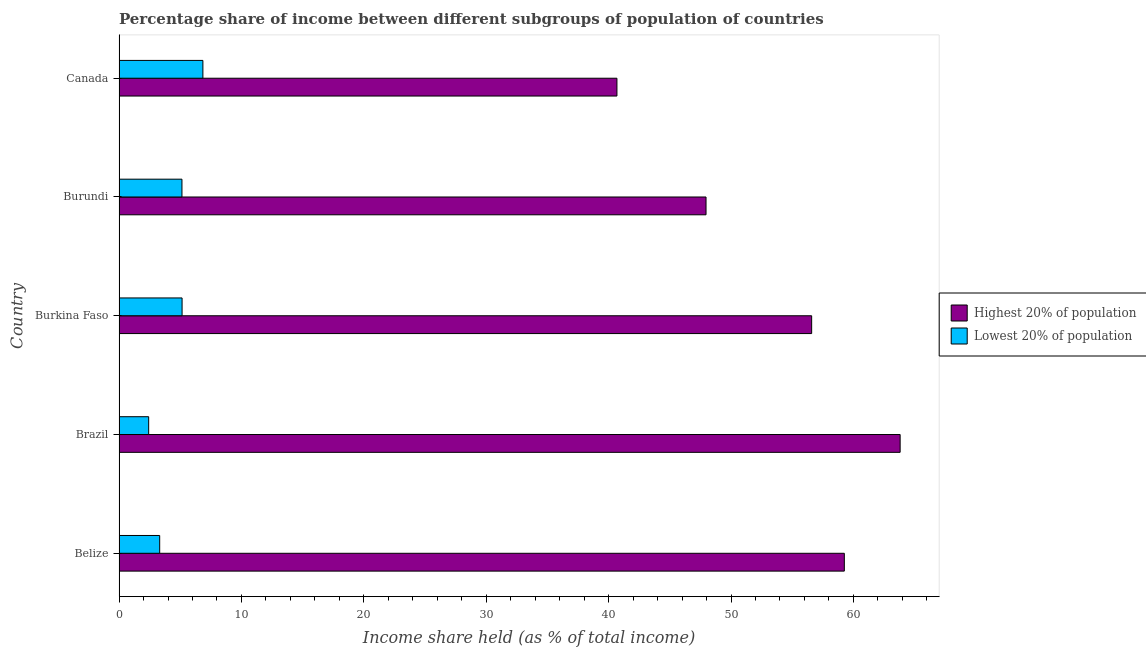How many groups of bars are there?
Your answer should be very brief. 5. Are the number of bars per tick equal to the number of legend labels?
Offer a very short reply. Yes. How many bars are there on the 2nd tick from the bottom?
Offer a terse response. 2. What is the label of the 2nd group of bars from the top?
Give a very brief answer. Burundi. In how many cases, is the number of bars for a given country not equal to the number of legend labels?
Offer a terse response. 0. What is the income share held by highest 20% of the population in Belize?
Your response must be concise. 59.26. Across all countries, what is the maximum income share held by highest 20% of the population?
Give a very brief answer. 63.82. Across all countries, what is the minimum income share held by lowest 20% of the population?
Keep it short and to the point. 2.42. In which country was the income share held by lowest 20% of the population minimum?
Provide a short and direct response. Brazil. What is the total income share held by highest 20% of the population in the graph?
Offer a terse response. 268.31. What is the difference between the income share held by highest 20% of the population in Belize and that in Burundi?
Offer a very short reply. 11.3. What is the difference between the income share held by lowest 20% of the population in Brazil and the income share held by highest 20% of the population in Burkina Faso?
Your answer should be very brief. -54.17. What is the average income share held by lowest 20% of the population per country?
Provide a short and direct response. 4.58. What is the difference between the income share held by highest 20% of the population and income share held by lowest 20% of the population in Burkina Faso?
Provide a short and direct response. 51.44. What is the ratio of the income share held by highest 20% of the population in Brazil to that in Burundi?
Give a very brief answer. 1.33. Is the income share held by lowest 20% of the population in Brazil less than that in Canada?
Give a very brief answer. Yes. Is the difference between the income share held by highest 20% of the population in Belize and Canada greater than the difference between the income share held by lowest 20% of the population in Belize and Canada?
Keep it short and to the point. Yes. What is the difference between the highest and the second highest income share held by lowest 20% of the population?
Offer a terse response. 1.7. What is the difference between the highest and the lowest income share held by highest 20% of the population?
Make the answer very short. 23.14. Is the sum of the income share held by lowest 20% of the population in Belize and Canada greater than the maximum income share held by highest 20% of the population across all countries?
Your response must be concise. No. What does the 2nd bar from the top in Burkina Faso represents?
Ensure brevity in your answer.  Highest 20% of population. What does the 2nd bar from the bottom in Canada represents?
Your answer should be very brief. Lowest 20% of population. What is the difference between two consecutive major ticks on the X-axis?
Your response must be concise. 10. Does the graph contain grids?
Provide a succinct answer. No. How many legend labels are there?
Offer a terse response. 2. How are the legend labels stacked?
Provide a short and direct response. Vertical. What is the title of the graph?
Your answer should be very brief. Percentage share of income between different subgroups of population of countries. What is the label or title of the X-axis?
Keep it short and to the point. Income share held (as % of total income). What is the label or title of the Y-axis?
Offer a terse response. Country. What is the Income share held (as % of total income) of Highest 20% of population in Belize?
Ensure brevity in your answer.  59.26. What is the Income share held (as % of total income) of Lowest 20% of population in Belize?
Your answer should be compact. 3.32. What is the Income share held (as % of total income) in Highest 20% of population in Brazil?
Your response must be concise. 63.82. What is the Income share held (as % of total income) of Lowest 20% of population in Brazil?
Your response must be concise. 2.42. What is the Income share held (as % of total income) in Highest 20% of population in Burkina Faso?
Your answer should be compact. 56.59. What is the Income share held (as % of total income) in Lowest 20% of population in Burkina Faso?
Provide a succinct answer. 5.15. What is the Income share held (as % of total income) in Highest 20% of population in Burundi?
Offer a very short reply. 47.96. What is the Income share held (as % of total income) in Lowest 20% of population in Burundi?
Ensure brevity in your answer.  5.14. What is the Income share held (as % of total income) in Highest 20% of population in Canada?
Keep it short and to the point. 40.68. What is the Income share held (as % of total income) in Lowest 20% of population in Canada?
Your answer should be very brief. 6.85. Across all countries, what is the maximum Income share held (as % of total income) in Highest 20% of population?
Offer a very short reply. 63.82. Across all countries, what is the maximum Income share held (as % of total income) of Lowest 20% of population?
Make the answer very short. 6.85. Across all countries, what is the minimum Income share held (as % of total income) of Highest 20% of population?
Your answer should be compact. 40.68. Across all countries, what is the minimum Income share held (as % of total income) of Lowest 20% of population?
Offer a terse response. 2.42. What is the total Income share held (as % of total income) of Highest 20% of population in the graph?
Offer a terse response. 268.31. What is the total Income share held (as % of total income) of Lowest 20% of population in the graph?
Keep it short and to the point. 22.88. What is the difference between the Income share held (as % of total income) of Highest 20% of population in Belize and that in Brazil?
Offer a terse response. -4.56. What is the difference between the Income share held (as % of total income) of Lowest 20% of population in Belize and that in Brazil?
Offer a terse response. 0.9. What is the difference between the Income share held (as % of total income) of Highest 20% of population in Belize and that in Burkina Faso?
Offer a very short reply. 2.67. What is the difference between the Income share held (as % of total income) in Lowest 20% of population in Belize and that in Burkina Faso?
Make the answer very short. -1.83. What is the difference between the Income share held (as % of total income) of Highest 20% of population in Belize and that in Burundi?
Your answer should be compact. 11.3. What is the difference between the Income share held (as % of total income) of Lowest 20% of population in Belize and that in Burundi?
Offer a very short reply. -1.82. What is the difference between the Income share held (as % of total income) in Highest 20% of population in Belize and that in Canada?
Make the answer very short. 18.58. What is the difference between the Income share held (as % of total income) of Lowest 20% of population in Belize and that in Canada?
Give a very brief answer. -3.53. What is the difference between the Income share held (as % of total income) in Highest 20% of population in Brazil and that in Burkina Faso?
Provide a succinct answer. 7.23. What is the difference between the Income share held (as % of total income) of Lowest 20% of population in Brazil and that in Burkina Faso?
Provide a short and direct response. -2.73. What is the difference between the Income share held (as % of total income) in Highest 20% of population in Brazil and that in Burundi?
Your response must be concise. 15.86. What is the difference between the Income share held (as % of total income) in Lowest 20% of population in Brazil and that in Burundi?
Ensure brevity in your answer.  -2.72. What is the difference between the Income share held (as % of total income) in Highest 20% of population in Brazil and that in Canada?
Your answer should be very brief. 23.14. What is the difference between the Income share held (as % of total income) in Lowest 20% of population in Brazil and that in Canada?
Provide a short and direct response. -4.43. What is the difference between the Income share held (as % of total income) of Highest 20% of population in Burkina Faso and that in Burundi?
Ensure brevity in your answer.  8.63. What is the difference between the Income share held (as % of total income) of Lowest 20% of population in Burkina Faso and that in Burundi?
Give a very brief answer. 0.01. What is the difference between the Income share held (as % of total income) in Highest 20% of population in Burkina Faso and that in Canada?
Offer a very short reply. 15.91. What is the difference between the Income share held (as % of total income) of Lowest 20% of population in Burkina Faso and that in Canada?
Provide a short and direct response. -1.7. What is the difference between the Income share held (as % of total income) in Highest 20% of population in Burundi and that in Canada?
Offer a very short reply. 7.28. What is the difference between the Income share held (as % of total income) in Lowest 20% of population in Burundi and that in Canada?
Ensure brevity in your answer.  -1.71. What is the difference between the Income share held (as % of total income) of Highest 20% of population in Belize and the Income share held (as % of total income) of Lowest 20% of population in Brazil?
Your answer should be very brief. 56.84. What is the difference between the Income share held (as % of total income) of Highest 20% of population in Belize and the Income share held (as % of total income) of Lowest 20% of population in Burkina Faso?
Provide a succinct answer. 54.11. What is the difference between the Income share held (as % of total income) of Highest 20% of population in Belize and the Income share held (as % of total income) of Lowest 20% of population in Burundi?
Keep it short and to the point. 54.12. What is the difference between the Income share held (as % of total income) of Highest 20% of population in Belize and the Income share held (as % of total income) of Lowest 20% of population in Canada?
Keep it short and to the point. 52.41. What is the difference between the Income share held (as % of total income) in Highest 20% of population in Brazil and the Income share held (as % of total income) in Lowest 20% of population in Burkina Faso?
Provide a succinct answer. 58.67. What is the difference between the Income share held (as % of total income) in Highest 20% of population in Brazil and the Income share held (as % of total income) in Lowest 20% of population in Burundi?
Make the answer very short. 58.68. What is the difference between the Income share held (as % of total income) in Highest 20% of population in Brazil and the Income share held (as % of total income) in Lowest 20% of population in Canada?
Your answer should be compact. 56.97. What is the difference between the Income share held (as % of total income) in Highest 20% of population in Burkina Faso and the Income share held (as % of total income) in Lowest 20% of population in Burundi?
Your answer should be compact. 51.45. What is the difference between the Income share held (as % of total income) of Highest 20% of population in Burkina Faso and the Income share held (as % of total income) of Lowest 20% of population in Canada?
Offer a very short reply. 49.74. What is the difference between the Income share held (as % of total income) in Highest 20% of population in Burundi and the Income share held (as % of total income) in Lowest 20% of population in Canada?
Keep it short and to the point. 41.11. What is the average Income share held (as % of total income) in Highest 20% of population per country?
Provide a succinct answer. 53.66. What is the average Income share held (as % of total income) of Lowest 20% of population per country?
Provide a succinct answer. 4.58. What is the difference between the Income share held (as % of total income) of Highest 20% of population and Income share held (as % of total income) of Lowest 20% of population in Belize?
Keep it short and to the point. 55.94. What is the difference between the Income share held (as % of total income) in Highest 20% of population and Income share held (as % of total income) in Lowest 20% of population in Brazil?
Offer a very short reply. 61.4. What is the difference between the Income share held (as % of total income) of Highest 20% of population and Income share held (as % of total income) of Lowest 20% of population in Burkina Faso?
Your answer should be compact. 51.44. What is the difference between the Income share held (as % of total income) in Highest 20% of population and Income share held (as % of total income) in Lowest 20% of population in Burundi?
Your answer should be compact. 42.82. What is the difference between the Income share held (as % of total income) in Highest 20% of population and Income share held (as % of total income) in Lowest 20% of population in Canada?
Give a very brief answer. 33.83. What is the ratio of the Income share held (as % of total income) in Highest 20% of population in Belize to that in Brazil?
Your answer should be compact. 0.93. What is the ratio of the Income share held (as % of total income) of Lowest 20% of population in Belize to that in Brazil?
Your answer should be very brief. 1.37. What is the ratio of the Income share held (as % of total income) of Highest 20% of population in Belize to that in Burkina Faso?
Ensure brevity in your answer.  1.05. What is the ratio of the Income share held (as % of total income) of Lowest 20% of population in Belize to that in Burkina Faso?
Keep it short and to the point. 0.64. What is the ratio of the Income share held (as % of total income) of Highest 20% of population in Belize to that in Burundi?
Your answer should be very brief. 1.24. What is the ratio of the Income share held (as % of total income) of Lowest 20% of population in Belize to that in Burundi?
Offer a terse response. 0.65. What is the ratio of the Income share held (as % of total income) in Highest 20% of population in Belize to that in Canada?
Offer a very short reply. 1.46. What is the ratio of the Income share held (as % of total income) of Lowest 20% of population in Belize to that in Canada?
Give a very brief answer. 0.48. What is the ratio of the Income share held (as % of total income) of Highest 20% of population in Brazil to that in Burkina Faso?
Make the answer very short. 1.13. What is the ratio of the Income share held (as % of total income) of Lowest 20% of population in Brazil to that in Burkina Faso?
Your response must be concise. 0.47. What is the ratio of the Income share held (as % of total income) in Highest 20% of population in Brazil to that in Burundi?
Provide a succinct answer. 1.33. What is the ratio of the Income share held (as % of total income) in Lowest 20% of population in Brazil to that in Burundi?
Your answer should be very brief. 0.47. What is the ratio of the Income share held (as % of total income) in Highest 20% of population in Brazil to that in Canada?
Keep it short and to the point. 1.57. What is the ratio of the Income share held (as % of total income) in Lowest 20% of population in Brazil to that in Canada?
Provide a short and direct response. 0.35. What is the ratio of the Income share held (as % of total income) of Highest 20% of population in Burkina Faso to that in Burundi?
Ensure brevity in your answer.  1.18. What is the ratio of the Income share held (as % of total income) of Lowest 20% of population in Burkina Faso to that in Burundi?
Your answer should be very brief. 1. What is the ratio of the Income share held (as % of total income) in Highest 20% of population in Burkina Faso to that in Canada?
Offer a very short reply. 1.39. What is the ratio of the Income share held (as % of total income) of Lowest 20% of population in Burkina Faso to that in Canada?
Your answer should be compact. 0.75. What is the ratio of the Income share held (as % of total income) in Highest 20% of population in Burundi to that in Canada?
Make the answer very short. 1.18. What is the ratio of the Income share held (as % of total income) of Lowest 20% of population in Burundi to that in Canada?
Ensure brevity in your answer.  0.75. What is the difference between the highest and the second highest Income share held (as % of total income) of Highest 20% of population?
Keep it short and to the point. 4.56. What is the difference between the highest and the lowest Income share held (as % of total income) of Highest 20% of population?
Give a very brief answer. 23.14. What is the difference between the highest and the lowest Income share held (as % of total income) of Lowest 20% of population?
Give a very brief answer. 4.43. 